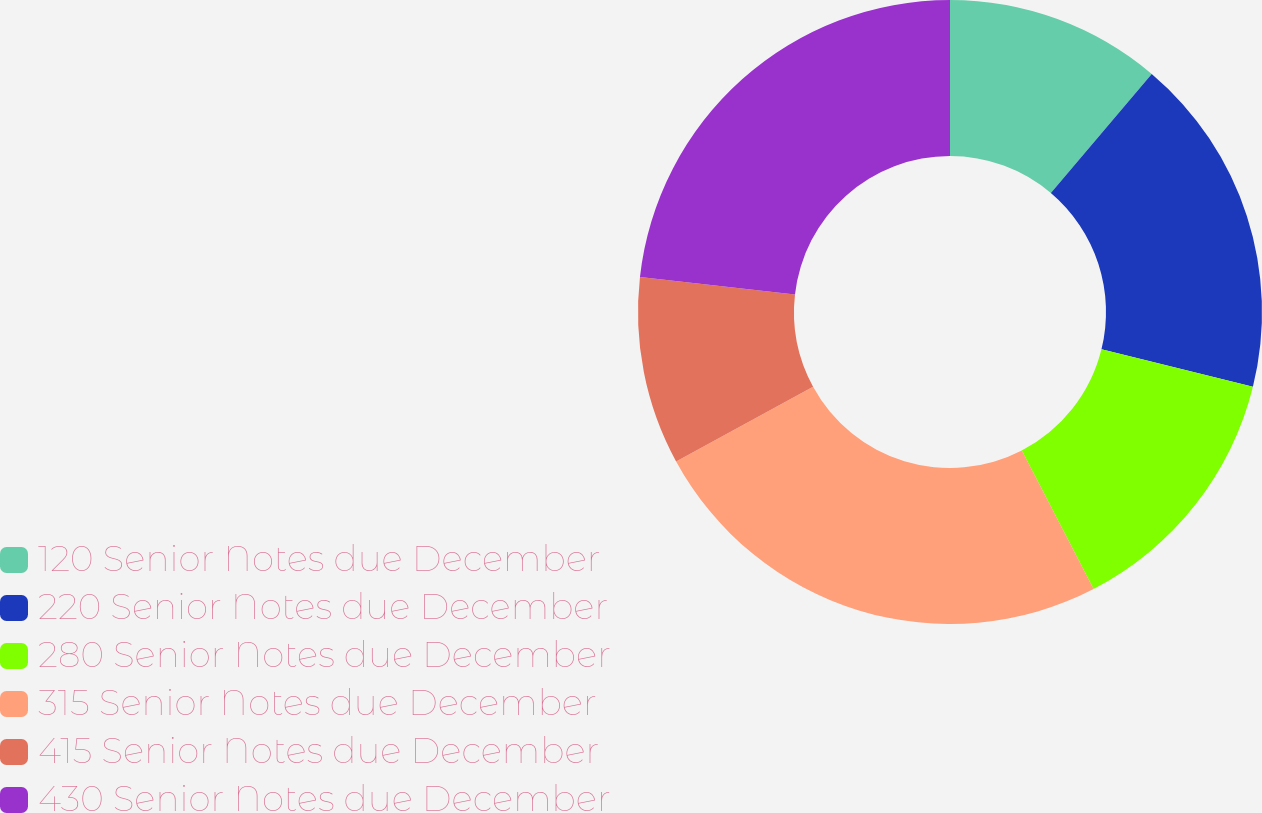<chart> <loc_0><loc_0><loc_500><loc_500><pie_chart><fcel>120 Senior Notes due December<fcel>220 Senior Notes due December<fcel>280 Senior Notes due December<fcel>315 Senior Notes due December<fcel>415 Senior Notes due December<fcel>430 Senior Notes due December<nl><fcel>11.19%<fcel>17.66%<fcel>13.54%<fcel>24.66%<fcel>9.74%<fcel>23.21%<nl></chart> 